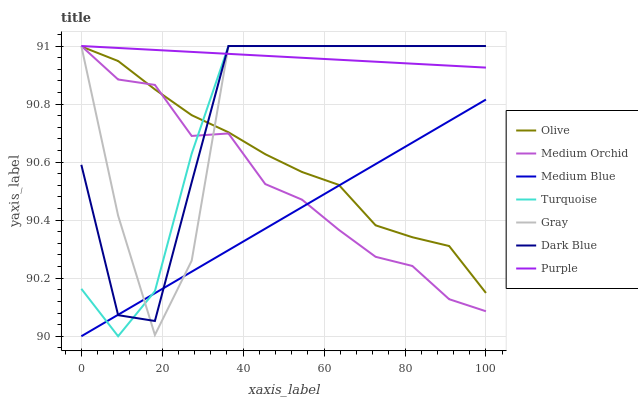Does Medium Blue have the minimum area under the curve?
Answer yes or no. Yes. Does Purple have the maximum area under the curve?
Answer yes or no. Yes. Does Turquoise have the minimum area under the curve?
Answer yes or no. No. Does Turquoise have the maximum area under the curve?
Answer yes or no. No. Is Medium Blue the smoothest?
Answer yes or no. Yes. Is Gray the roughest?
Answer yes or no. Yes. Is Turquoise the smoothest?
Answer yes or no. No. Is Turquoise the roughest?
Answer yes or no. No. Does Turquoise have the lowest value?
Answer yes or no. No. Does Dark Blue have the highest value?
Answer yes or no. Yes. Does Medium Blue have the highest value?
Answer yes or no. No. Is Olive less than Purple?
Answer yes or no. Yes. Is Purple greater than Olive?
Answer yes or no. Yes. Does Dark Blue intersect Turquoise?
Answer yes or no. Yes. Is Dark Blue less than Turquoise?
Answer yes or no. No. Is Dark Blue greater than Turquoise?
Answer yes or no. No. Does Olive intersect Purple?
Answer yes or no. No. 